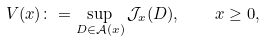<formula> <loc_0><loc_0><loc_500><loc_500>V ( x ) \colon = \sup _ { D \in \mathcal { A } ( x ) } \mathcal { J } _ { x } ( D ) , \quad x \geq 0 ,</formula> 